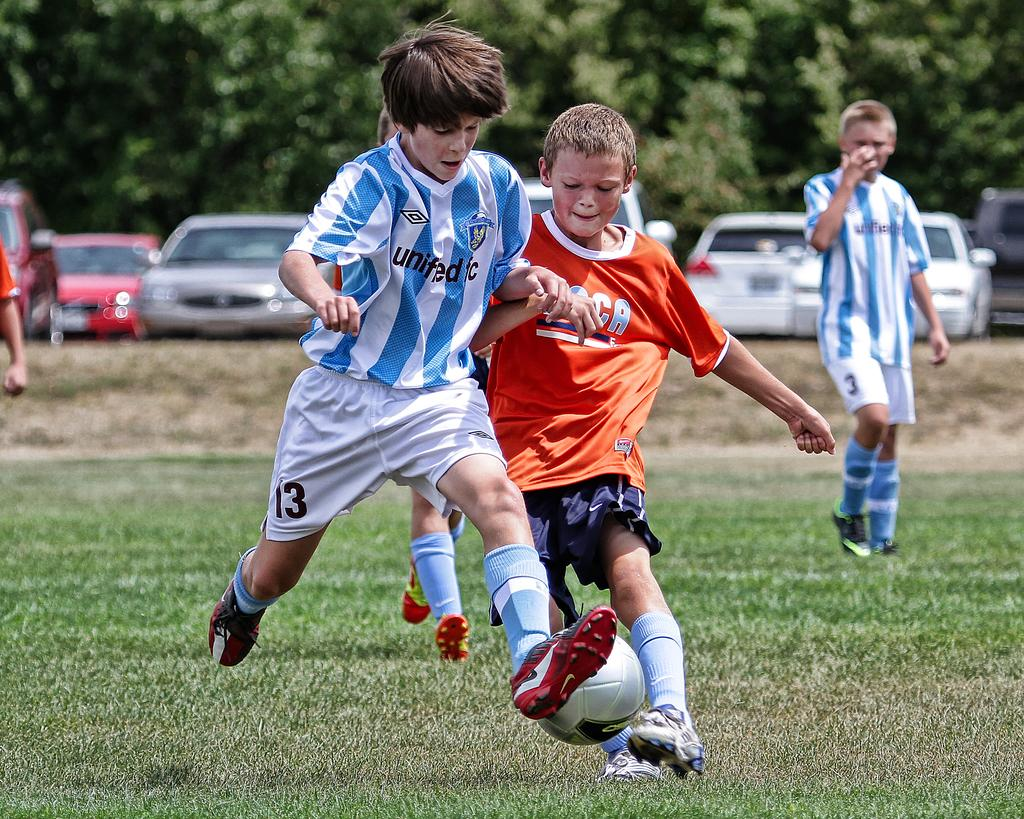Where was the image taken? The image was taken in a ground. How many children are present in the image? There are four children in the image. What are the children doing in the image? The children are playing a game. What object is involved in their game? There is a ball in the image. What can be seen in the background of the image? There are trees visible in the image. Are there any vehicles in the image? Yes, there are cars in the image. How many doors can be seen in the image? There are no doors visible in the image. What type of potato is being used as a prop in the game? There is no potato present in the image; the children are playing with a ball. Are there any horses visible in the image? No, there are no horses present in the image. 